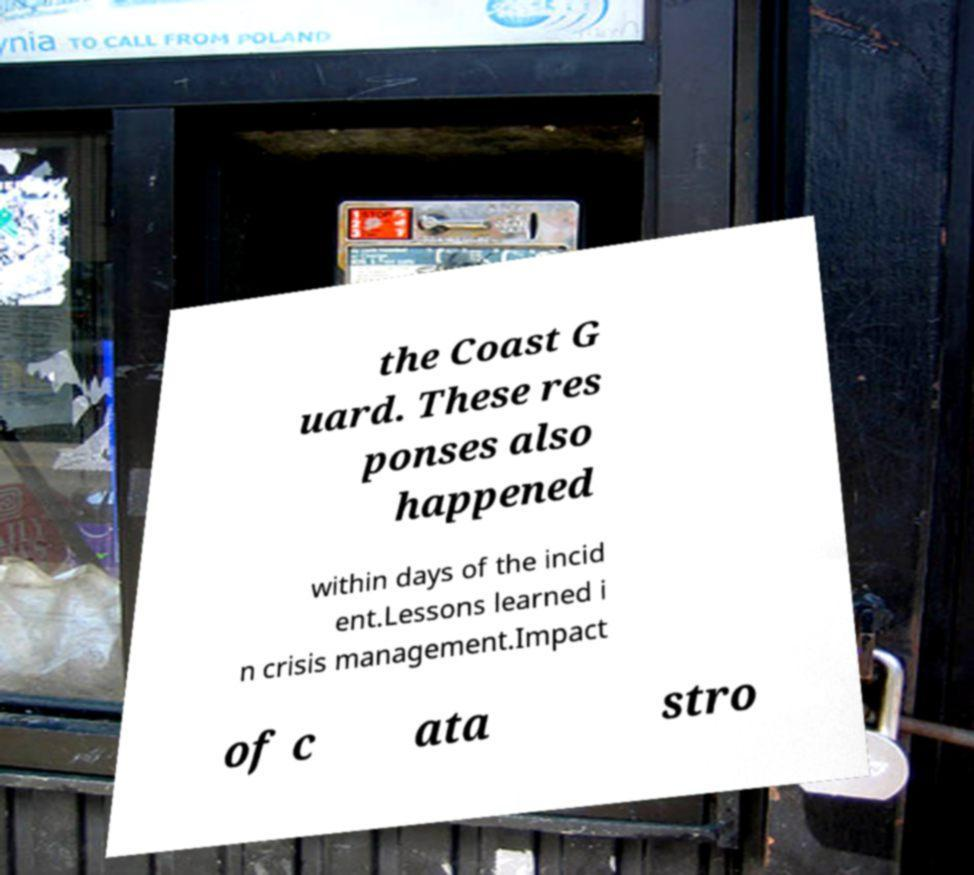Can you read and provide the text displayed in the image?This photo seems to have some interesting text. Can you extract and type it out for me? the Coast G uard. These res ponses also happened within days of the incid ent.Lessons learned i n crisis management.Impact of c ata stro 